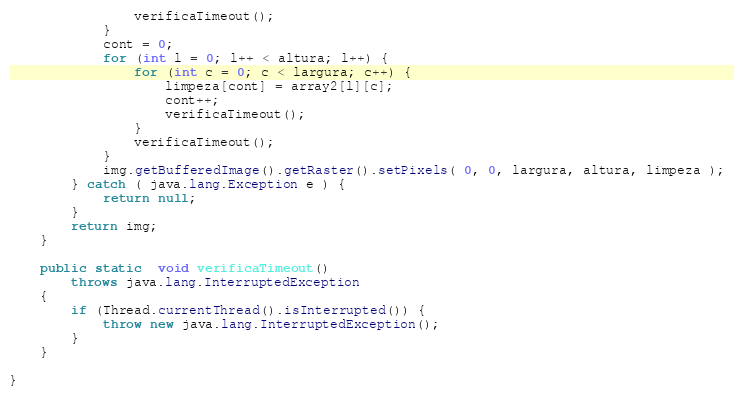<code> <loc_0><loc_0><loc_500><loc_500><_Java_>                verificaTimeout();
            }
            cont = 0;
            for (int l = 0; l++ < altura; l++) {
                for (int c = 0; c < largura; c++) {
                    limpeza[cont] = array2[l][c];
                    cont++;
                    verificaTimeout();
                }
                verificaTimeout();
            }
            img.getBufferedImage().getRaster().setPixels( 0, 0, largura, altura, limpeza );
        } catch ( java.lang.Exception e ) {
            return null;
        }
        return img;
    }

    public static  void verificaTimeout()
        throws java.lang.InterruptedException
    {
        if (Thread.currentThread().isInterrupted()) {
            throw new java.lang.InterruptedException();
        }
    }

}
</code> 